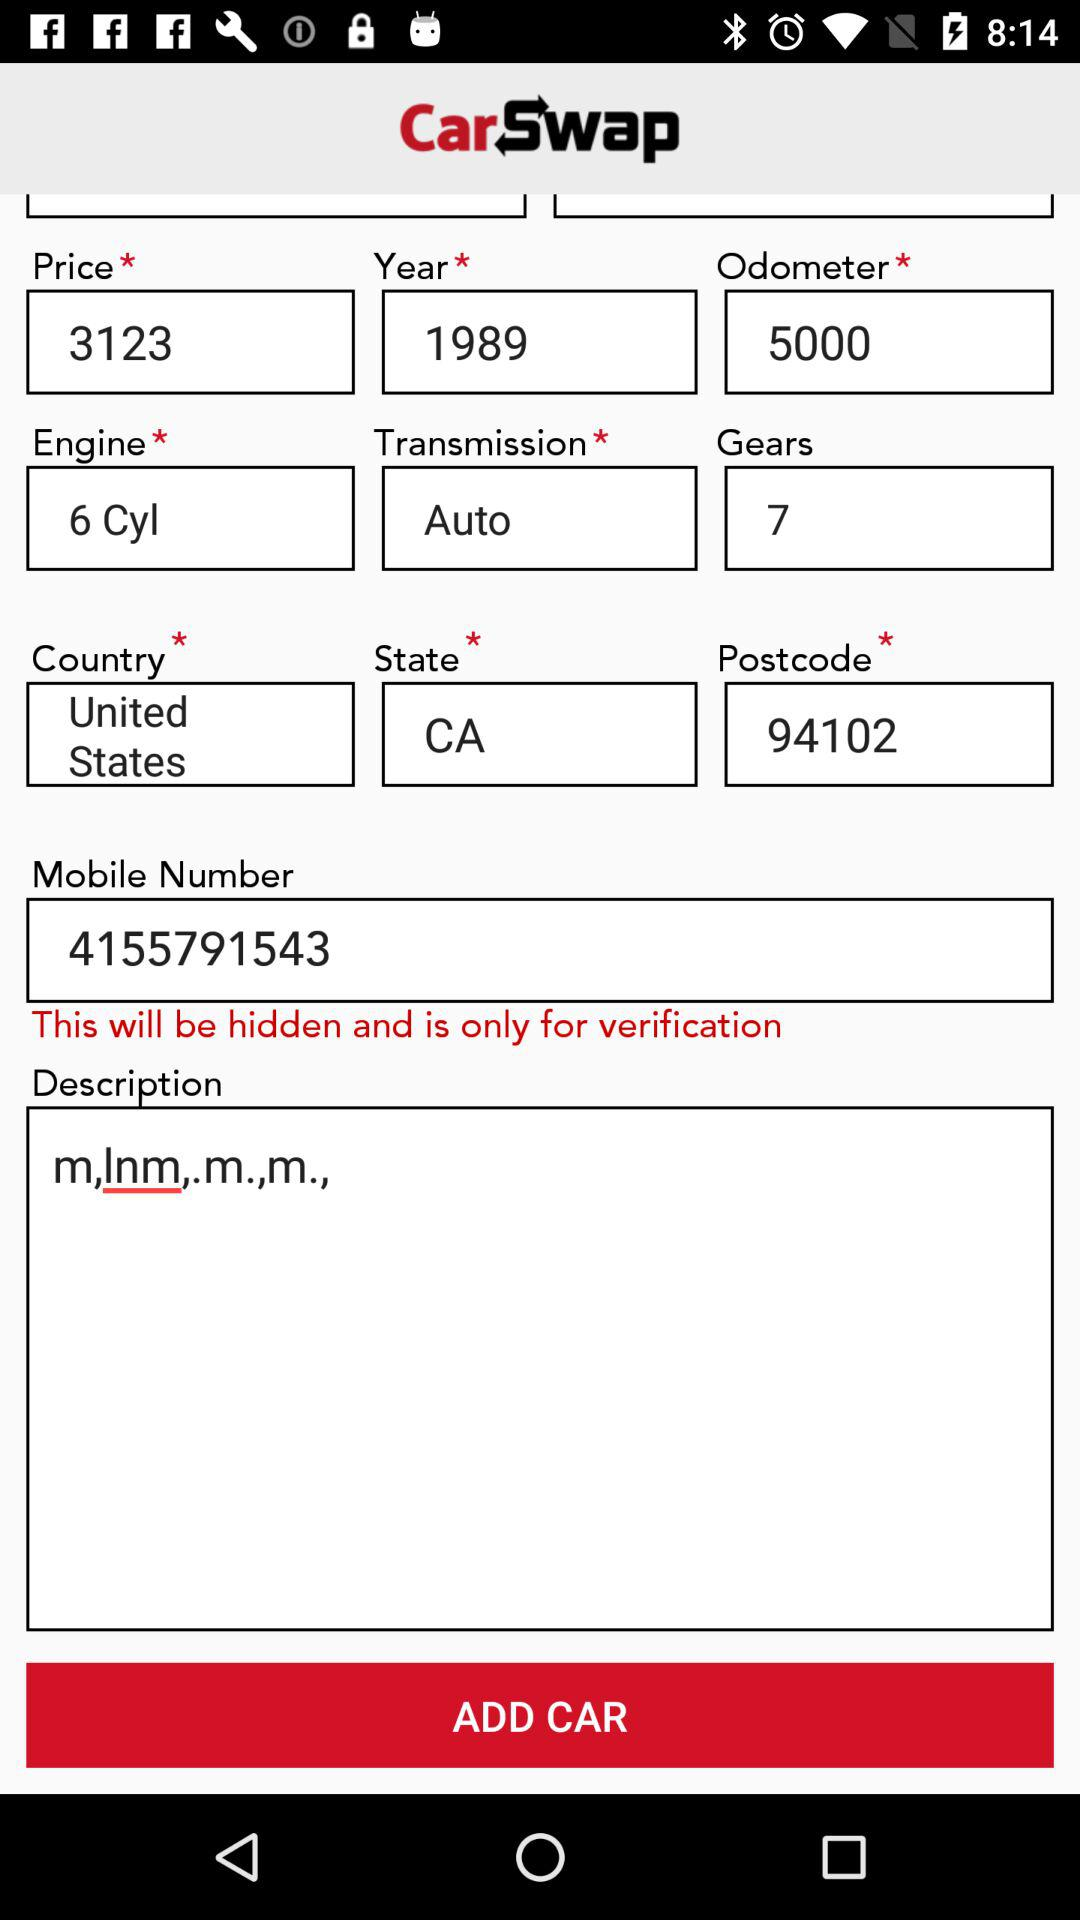What is the mobile number for the verification? The mobile number is 4155791543. 